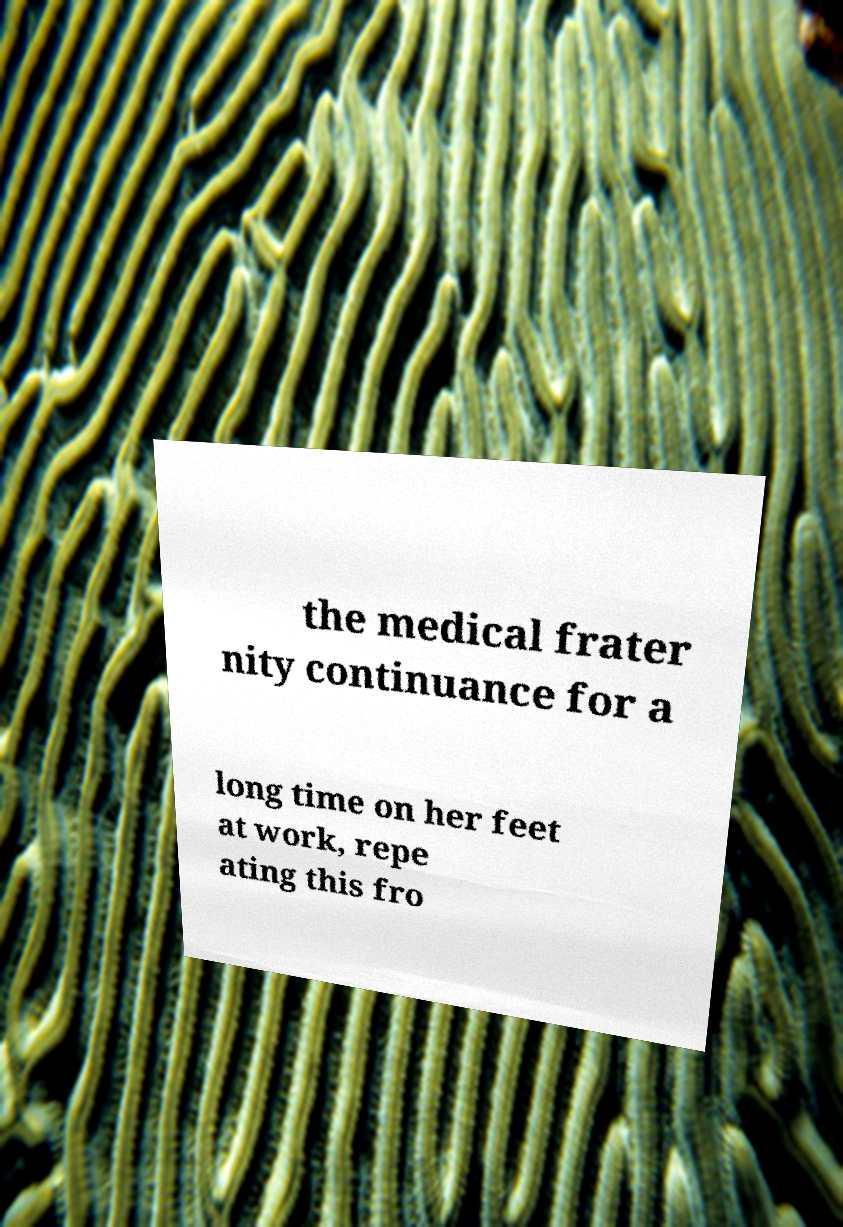There's text embedded in this image that I need extracted. Can you transcribe it verbatim? the medical frater nity continuance for a long time on her feet at work, repe ating this fro 